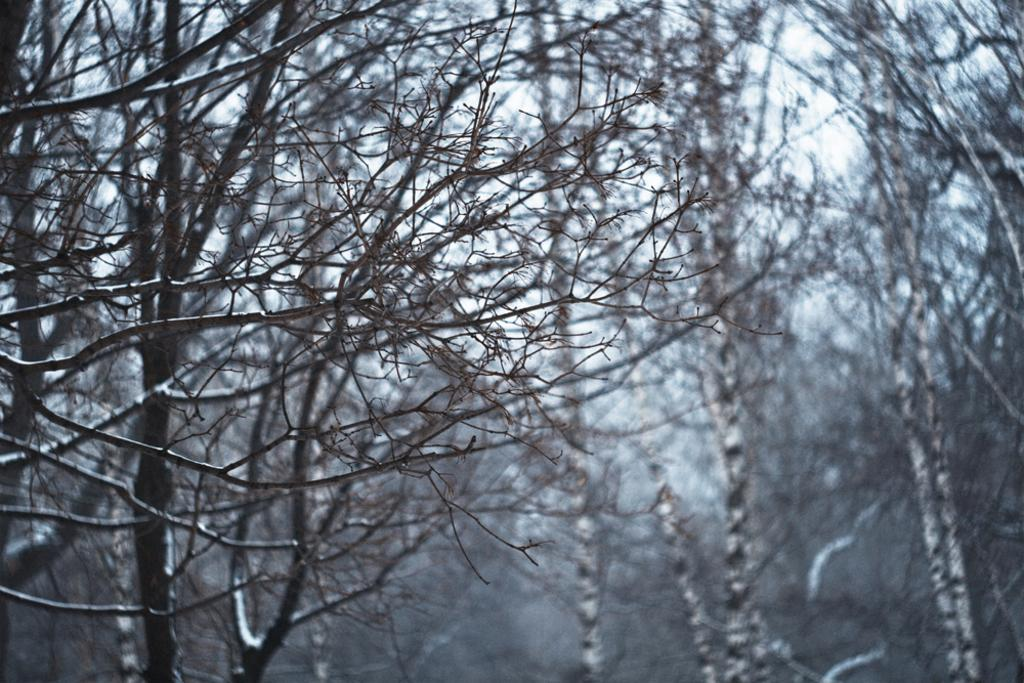What type of vegetation can be seen in the image? There are trees in the image. What part of the natural environment is visible in the image? The sky is visible in the background of the image. What type of mask is being worn by the vegetable in the image? There are no masks or vegetables present in the image; it features trees and the sky. 